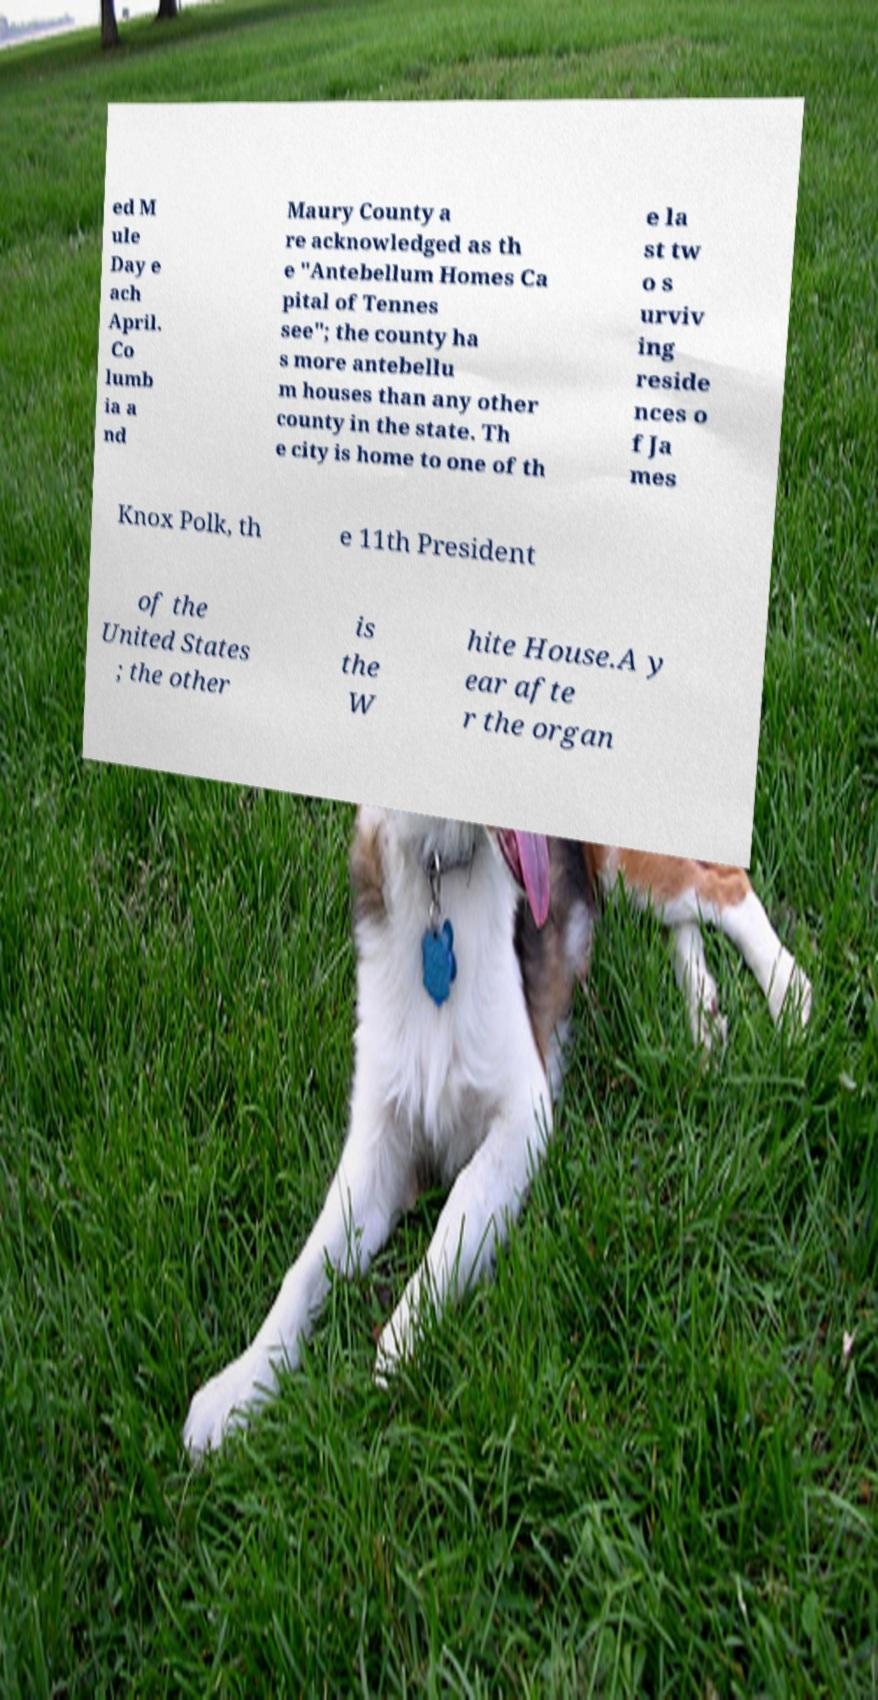Could you assist in decoding the text presented in this image and type it out clearly? ed M ule Day e ach April. Co lumb ia a nd Maury County a re acknowledged as th e "Antebellum Homes Ca pital of Tennes see"; the county ha s more antebellu m houses than any other county in the state. Th e city is home to one of th e la st tw o s urviv ing reside nces o f Ja mes Knox Polk, th e 11th President of the United States ; the other is the W hite House.A y ear afte r the organ 